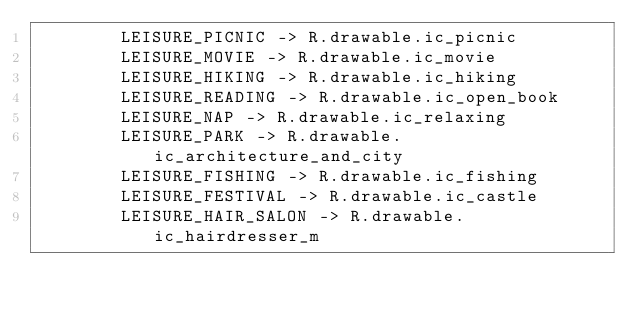<code> <loc_0><loc_0><loc_500><loc_500><_Kotlin_>        LEISURE_PICNIC -> R.drawable.ic_picnic
        LEISURE_MOVIE -> R.drawable.ic_movie
        LEISURE_HIKING -> R.drawable.ic_hiking
        LEISURE_READING -> R.drawable.ic_open_book
        LEISURE_NAP -> R.drawable.ic_relaxing
        LEISURE_PARK -> R.drawable.ic_architecture_and_city
        LEISURE_FISHING -> R.drawable.ic_fishing
        LEISURE_FESTIVAL -> R.drawable.ic_castle
        LEISURE_HAIR_SALON -> R.drawable.ic_hairdresser_m</code> 